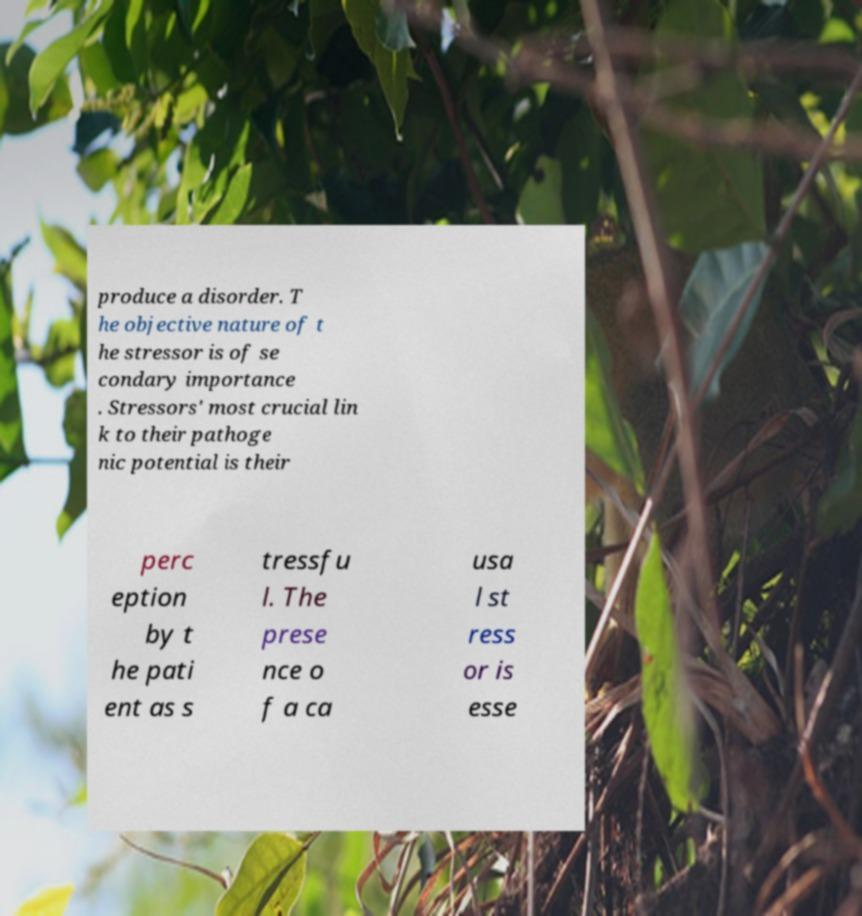I need the written content from this picture converted into text. Can you do that? produce a disorder. T he objective nature of t he stressor is of se condary importance . Stressors' most crucial lin k to their pathoge nic potential is their perc eption by t he pati ent as s tressfu l. The prese nce o f a ca usa l st ress or is esse 